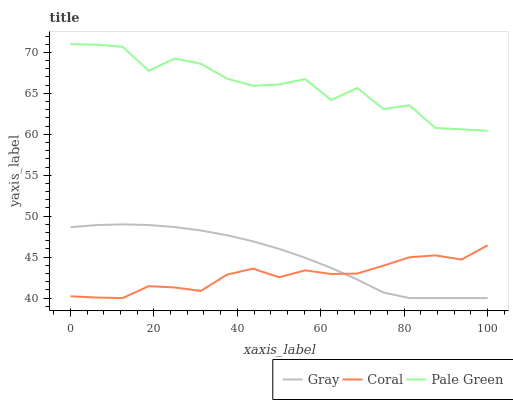Does Coral have the minimum area under the curve?
Answer yes or no. Yes. Does Pale Green have the maximum area under the curve?
Answer yes or no. Yes. Does Pale Green have the minimum area under the curve?
Answer yes or no. No. Does Coral have the maximum area under the curve?
Answer yes or no. No. Is Gray the smoothest?
Answer yes or no. Yes. Is Pale Green the roughest?
Answer yes or no. Yes. Is Coral the smoothest?
Answer yes or no. No. Is Coral the roughest?
Answer yes or no. No. Does Pale Green have the lowest value?
Answer yes or no. No. Does Pale Green have the highest value?
Answer yes or no. Yes. Does Coral have the highest value?
Answer yes or no. No. Is Gray less than Pale Green?
Answer yes or no. Yes. Is Pale Green greater than Coral?
Answer yes or no. Yes. Does Gray intersect Coral?
Answer yes or no. Yes. Is Gray less than Coral?
Answer yes or no. No. Is Gray greater than Coral?
Answer yes or no. No. Does Gray intersect Pale Green?
Answer yes or no. No. 